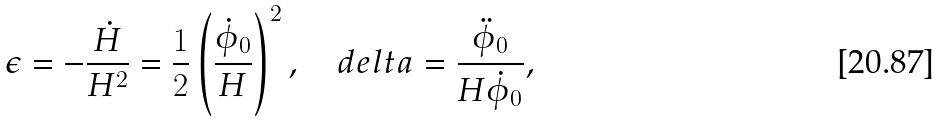Convert formula to latex. <formula><loc_0><loc_0><loc_500><loc_500>\epsilon = - \frac { \dot { H } } { H ^ { 2 } } = \frac { 1 } { 2 } \left ( \frac { \dot { \phi } _ { 0 } } { H } \right ) ^ { 2 } , \quad d e l t a = \frac { \ddot { \phi } _ { 0 } } { H \dot { \phi } _ { 0 } } ,</formula> 